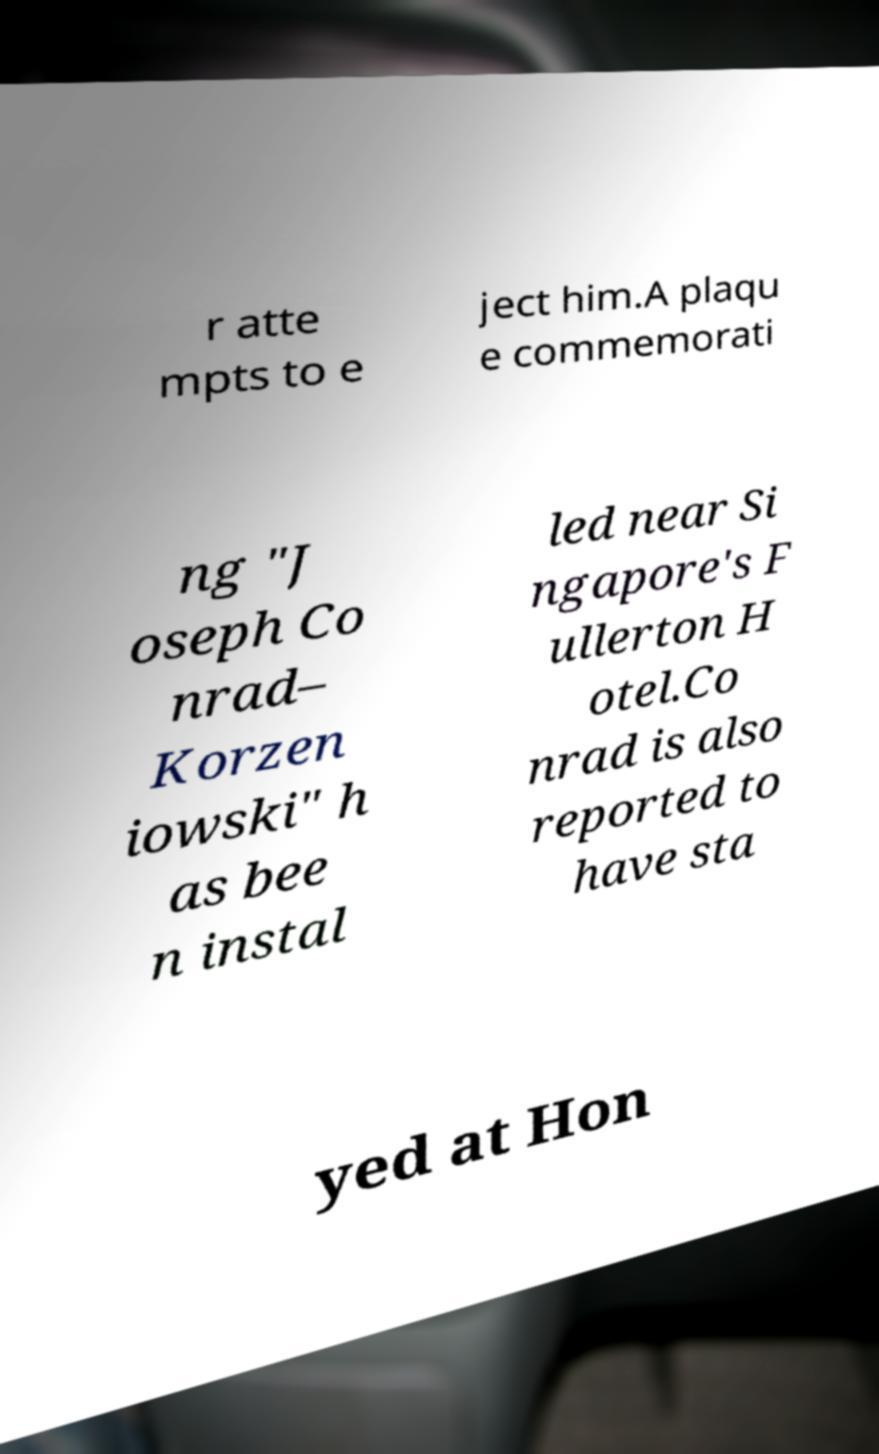I need the written content from this picture converted into text. Can you do that? r atte mpts to e ject him.A plaqu e commemorati ng "J oseph Co nrad– Korzen iowski" h as bee n instal led near Si ngapore's F ullerton H otel.Co nrad is also reported to have sta yed at Hon 